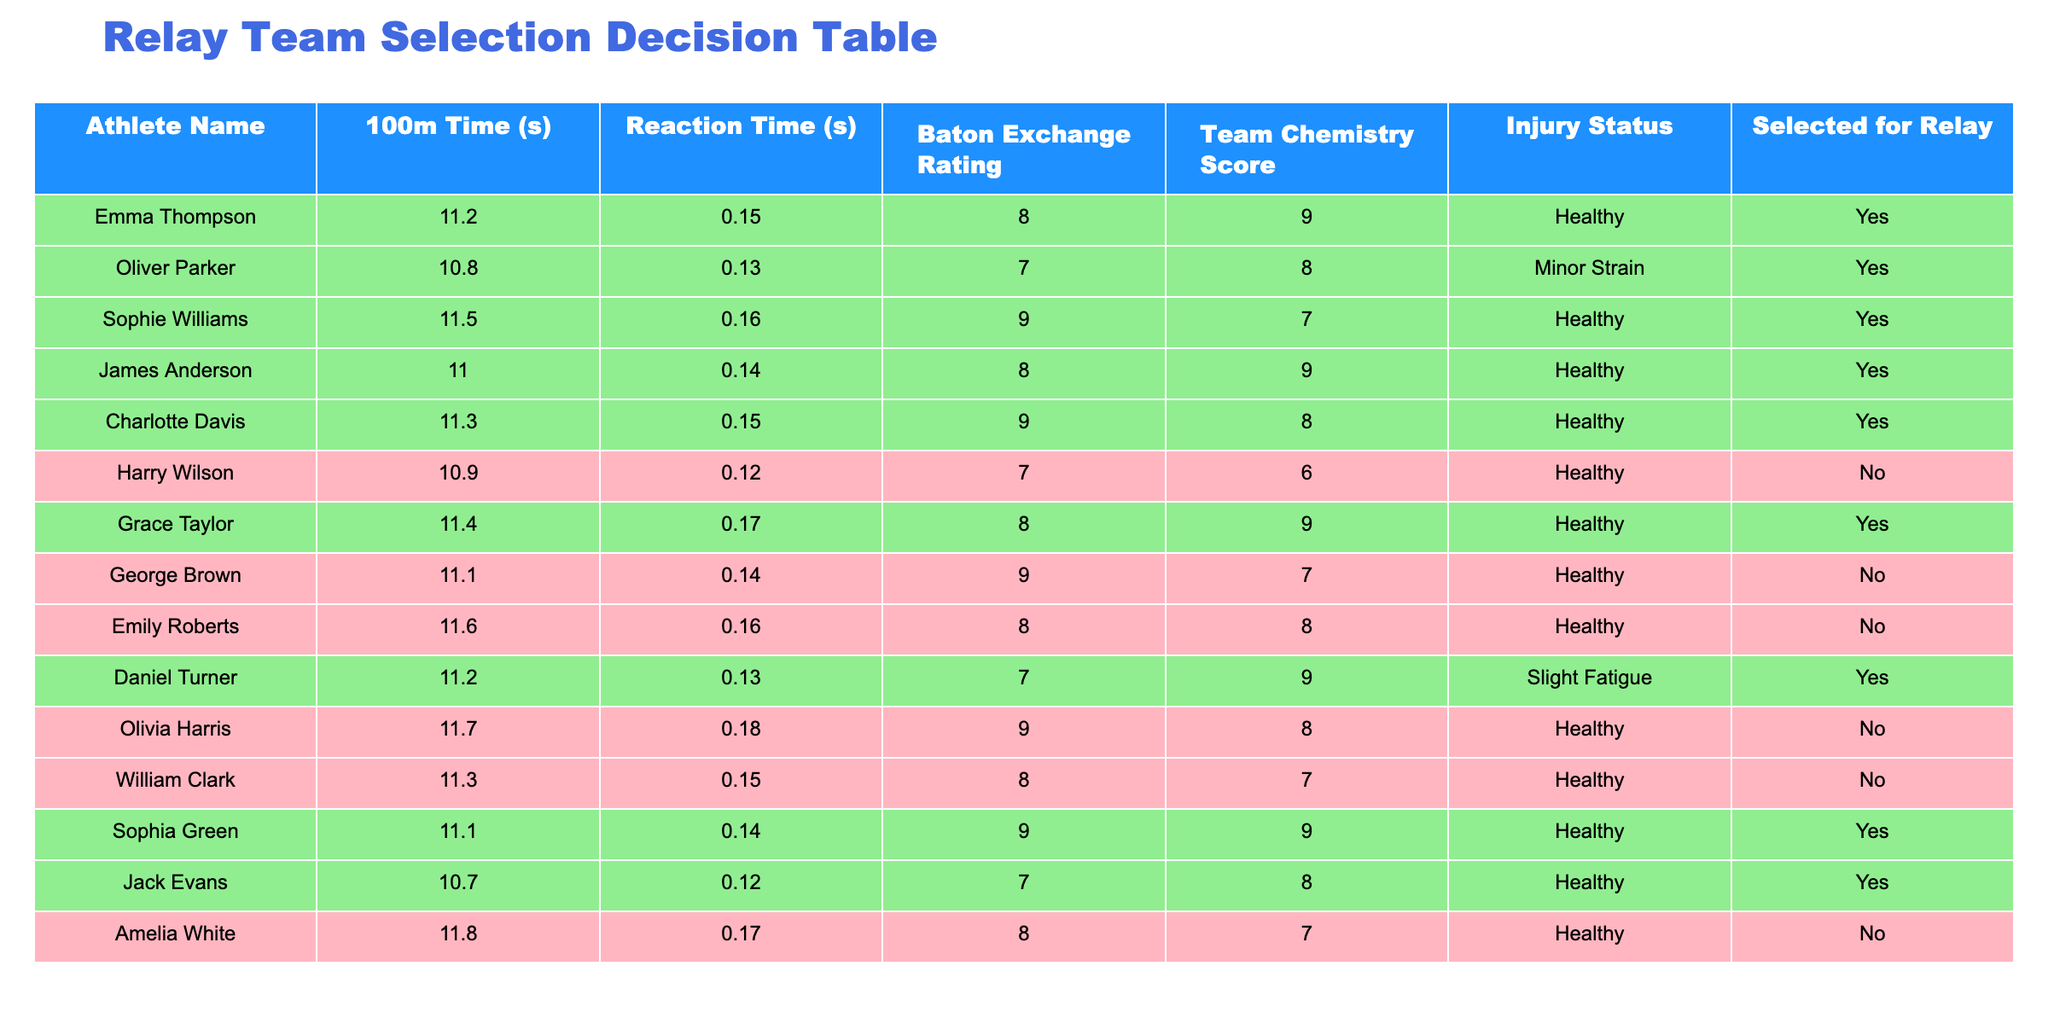What is the 100m time of Oliver Parker? Oliver Parker's 100m time is listed in the second row of the table. Referring directly to the table, his time is recorded as 10.8 seconds.
Answer: 10.8 seconds How many athletes have a healthy injury status and were selected for the relay? By reviewing the table, I can see which athletes are marked as "Healthy" in the Injury Status column and have "Yes" in the Selected for Relay column. The selected athletes are Emma Thompson, Oliver Parker, Sophie Williams, James Anderson, Charlotte Davis, Grace Taylor, Daniel Turner, Sophia Green, and Jack Evans. Counting these, we find there are 9 athletes.
Answer: 9 What is the average Team Chemistry Score of those who were selected for the relay? I will calculate the average of the Team Chemistry Scores for the athletes marked "Yes" in the Selected for Relay column. The scores are: 9, 8, 7, 9, 8, 9, 9, 8, and 8. Summing these gives 8 + 9 + 7 + 9 + 8 + 9 + 9 + 8 + 8 = 81. There are 9 athletes, so the average is 81/9 = 9.
Answer: 9 Is there any athlete who was not selected for the relay but has a Team Chemistry Score of 9? To answer, I check the Selected for Relay column for athletes with a score of 9 in the Team Chemistry Score column. The table shows that George Brown is marked as "No" for being selected but has a Team Chemistry Score of 9. Thus, the answer is yes.
Answer: Yes Which athlete has the lowest Reaction Time among those selected for the relay? I’ll look at the Reaction Time of each athlete who was selected for the relay. The selected athletes and their Reaction Times are: Emma Thompson (0.15), Oliver Parker (0.13), Sophie Williams (0.16), James Anderson (0.14), Charlotte Davis (0.15), Grace Taylor (0.17), Daniel Turner (0.13), Sophia Green (0.14), and Jack Evans (0.12). The lowest Reaction Time is 0.12 seconds, which belongs to Jack Evans.
Answer: Jack Evans How many athletes have a 100m Time greater than 11.5 seconds who were not selected for the relay? From the table, I will identify athletes with a 100m Time greater than 11.5 seconds who have "No" under Selected for Relay. The athletes are: Emily Roberts (11.6), Olivia Harris (11.7), and Amelia White (11.8). There are 3 athletes in total.
Answer: 3 